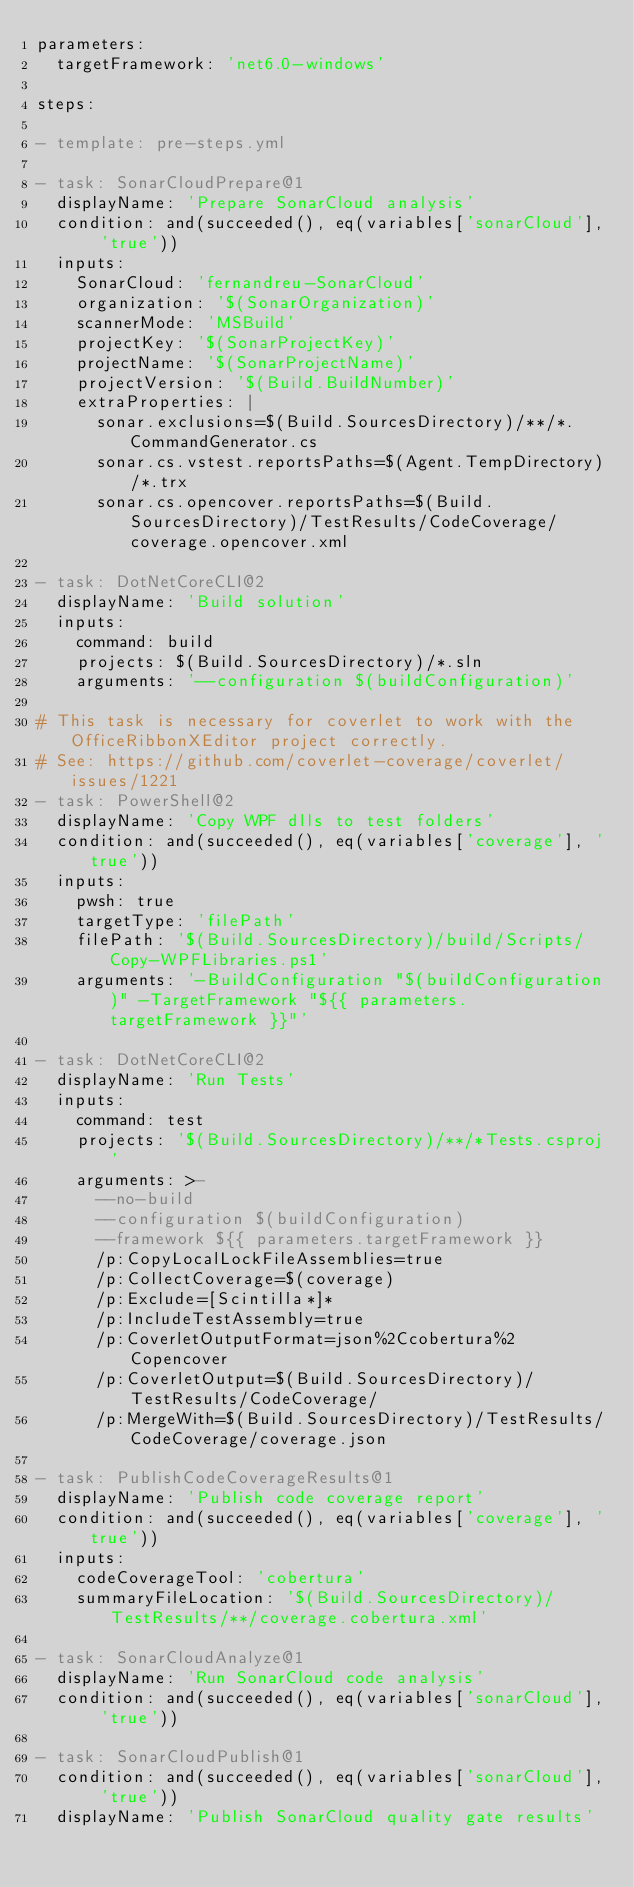Convert code to text. <code><loc_0><loc_0><loc_500><loc_500><_YAML_>parameters:
  targetFramework: 'net6.0-windows'

steps:

- template: pre-steps.yml

- task: SonarCloudPrepare@1
  displayName: 'Prepare SonarCloud analysis'
  condition: and(succeeded(), eq(variables['sonarCloud'], 'true'))
  inputs:
    SonarCloud: 'fernandreu-SonarCloud'
    organization: '$(SonarOrganization)'
    scannerMode: 'MSBuild'
    projectKey: '$(SonarProjectKey)'
    projectName: '$(SonarProjectName)'
    projectVersion: '$(Build.BuildNumber)'
    extraProperties: |
      sonar.exclusions=$(Build.SourcesDirectory)/**/*.CommandGenerator.cs
      sonar.cs.vstest.reportsPaths=$(Agent.TempDirectory)/*.trx
      sonar.cs.opencover.reportsPaths=$(Build.SourcesDirectory)/TestResults/CodeCoverage/coverage.opencover.xml

- task: DotNetCoreCLI@2
  displayName: 'Build solution'
  inputs:
    command: build
    projects: $(Build.SourcesDirectory)/*.sln
    arguments: '--configuration $(buildConfiguration)'
    
# This task is necessary for coverlet to work with the OfficeRibbonXEditor project correctly.
# See: https://github.com/coverlet-coverage/coverlet/issues/1221
- task: PowerShell@2
  displayName: 'Copy WPF dlls to test folders'
  condition: and(succeeded(), eq(variables['coverage'], 'true'))
  inputs:
    pwsh: true
    targetType: 'filePath'
    filePath: '$(Build.SourcesDirectory)/build/Scripts/Copy-WPFLibraries.ps1'
    arguments: '-BuildConfiguration "$(buildConfiguration)" -TargetFramework "${{ parameters.targetFramework }}"'

- task: DotNetCoreCLI@2
  displayName: 'Run Tests'
  inputs:
    command: test
    projects: '$(Build.SourcesDirectory)/**/*Tests.csproj'
    arguments: >-
      --no-build
      --configuration $(buildConfiguration)
      --framework ${{ parameters.targetFramework }}
      /p:CopyLocalLockFileAssemblies=true
      /p:CollectCoverage=$(coverage)
      /p:Exclude=[Scintilla*]*
      /p:IncludeTestAssembly=true
      /p:CoverletOutputFormat=json%2Ccobertura%2Copencover
      /p:CoverletOutput=$(Build.SourcesDirectory)/TestResults/CodeCoverage/
      /p:MergeWith=$(Build.SourcesDirectory)/TestResults/CodeCoverage/coverage.json

- task: PublishCodeCoverageResults@1
  displayName: 'Publish code coverage report'
  condition: and(succeeded(), eq(variables['coverage'], 'true'))
  inputs:
    codeCoverageTool: 'cobertura'
    summaryFileLocation: '$(Build.SourcesDirectory)/TestResults/**/coverage.cobertura.xml'

- task: SonarCloudAnalyze@1
  displayName: 'Run SonarCloud code analysis'
  condition: and(succeeded(), eq(variables['sonarCloud'], 'true'))

- task: SonarCloudPublish@1
  condition: and(succeeded(), eq(variables['sonarCloud'], 'true'))
  displayName: 'Publish SonarCloud quality gate results'
</code> 